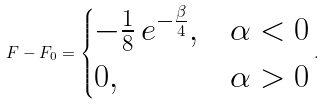<formula> <loc_0><loc_0><loc_500><loc_500>F - F _ { 0 } = \begin{cases} - \frac { 1 } { 8 } \, e ^ { - \frac { \beta } { 4 } } , & \alpha < 0 \\ 0 , & \alpha > 0 \end{cases} .</formula> 